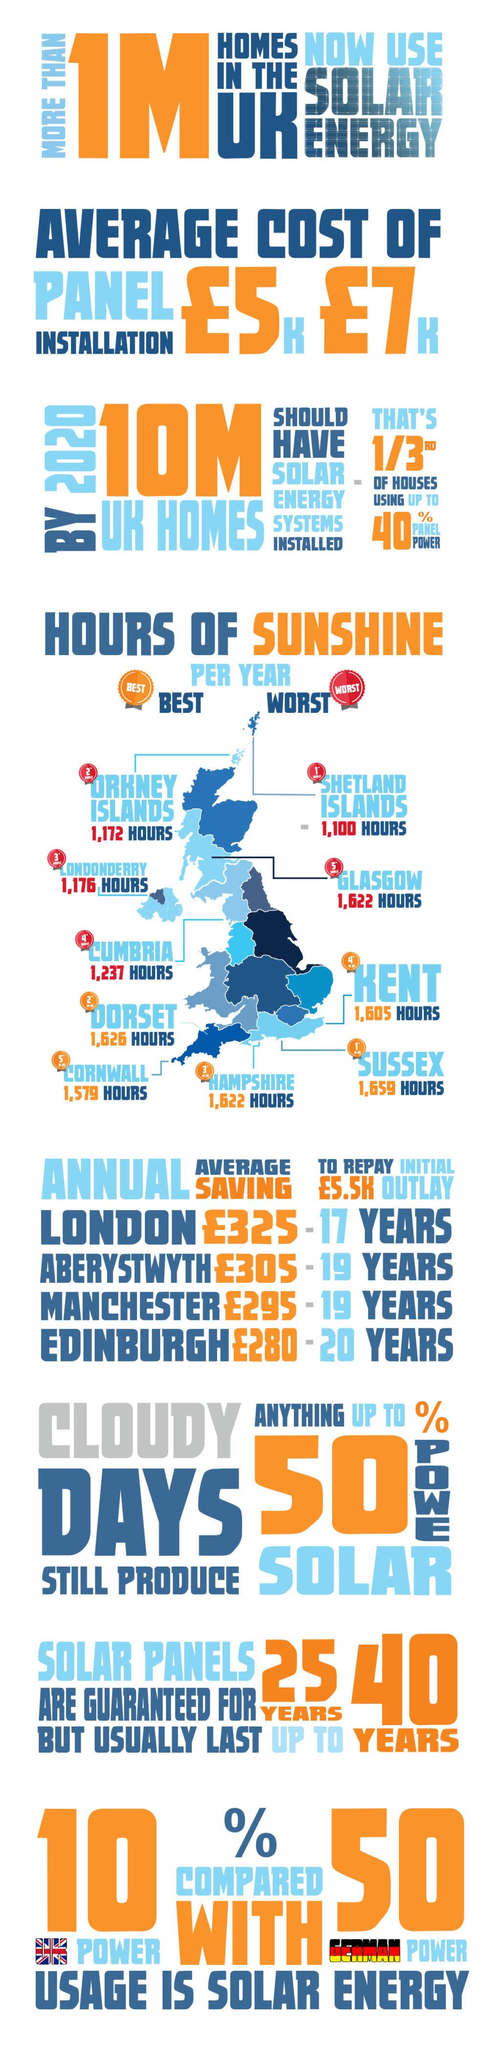Point out several critical features in this image. According to recent data, Germany's solar energy usage currently stands at approximately 50%. The Shetland Islands, Orkney Islands, and Londonderry are ranked among the top three counties with the worst hours of sunshine. Solar panels are expected to last for approximately 40 years under normal conditions. The Shetland Islands had the least hours of sunshine each year, making it the county with the least amount of sunlight. London has the highest annual average savings from panel power, with a total of 325 pounds. 